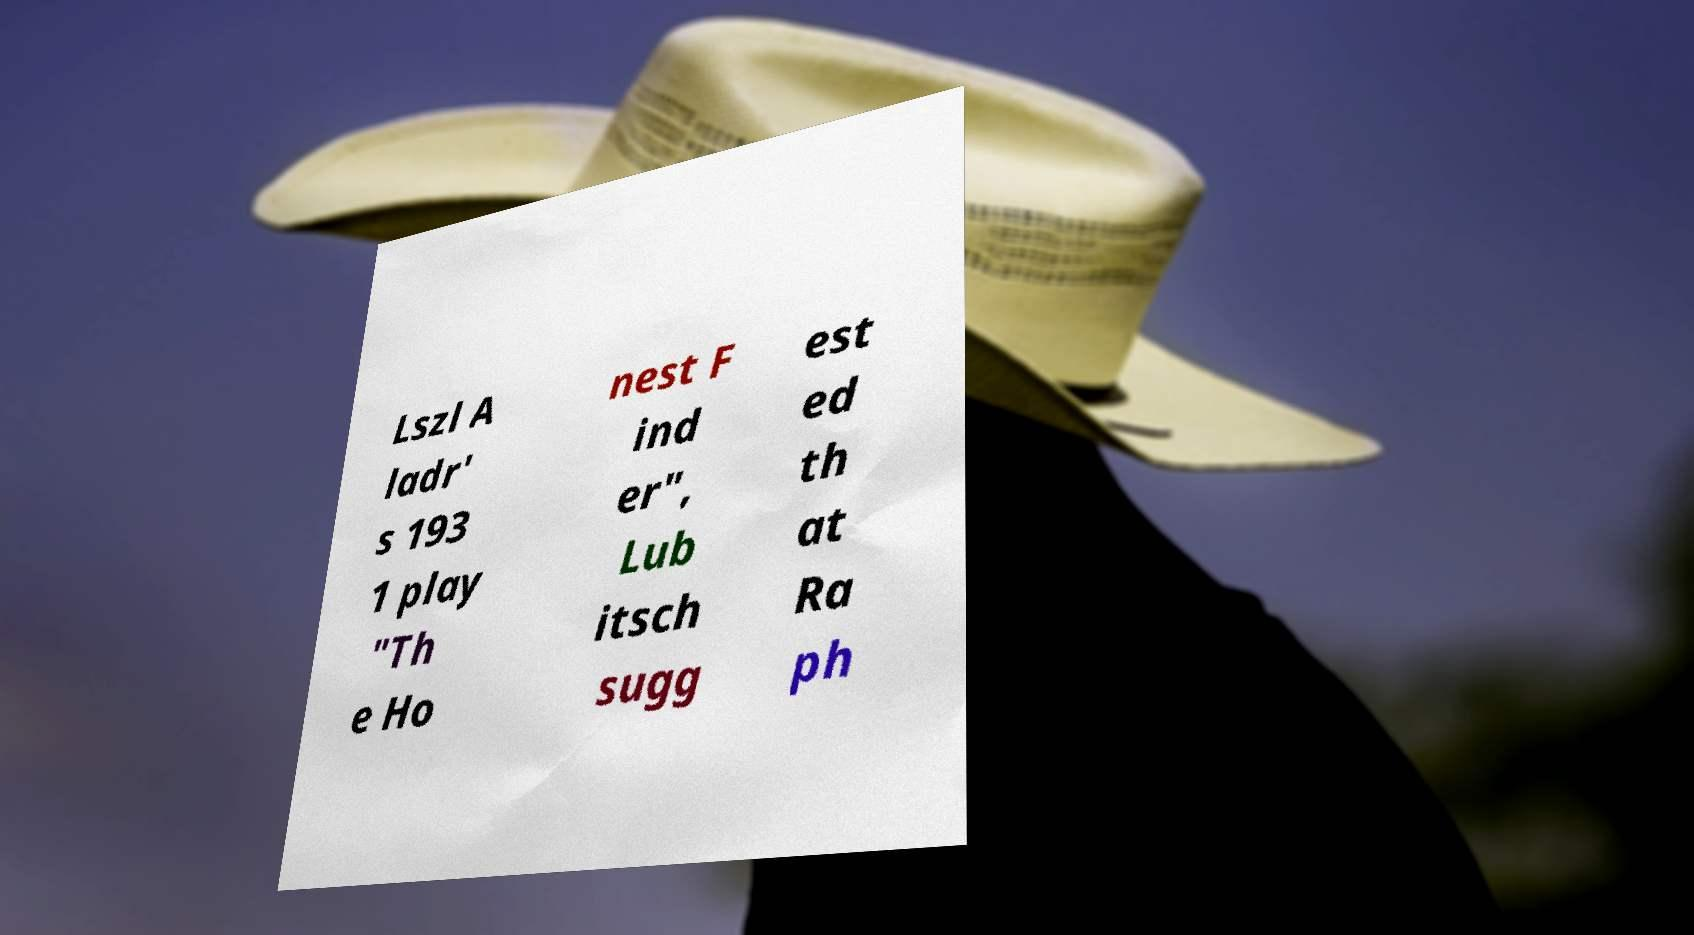For documentation purposes, I need the text within this image transcribed. Could you provide that? Lszl A ladr' s 193 1 play "Th e Ho nest F ind er", Lub itsch sugg est ed th at Ra ph 